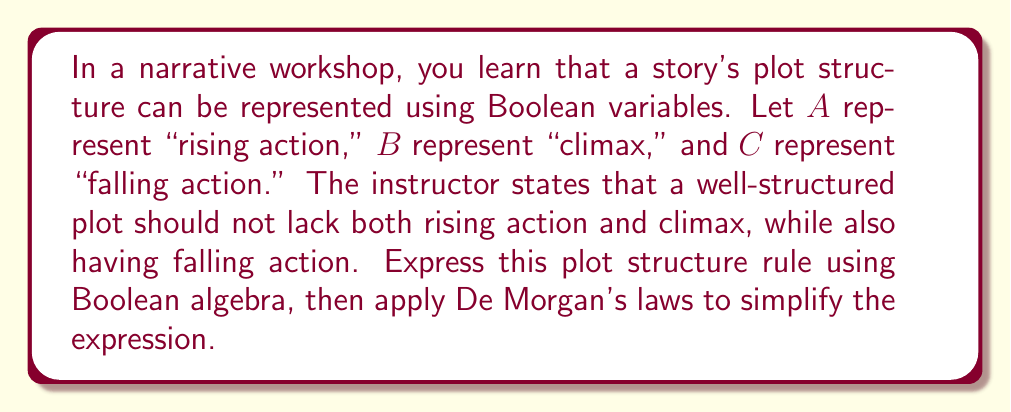Could you help me with this problem? Let's approach this step-by-step:

1. First, let's express the plot structure rule in Boolean algebra:
   $$((\overline{A} \cdot \overline{B}) + C)$$

   This reads as "not (no rising action and no climax) or falling action"

2. To apply De Morgan's laws, we need to negate this entire expression:
   $$\overline{((\overline{A} \cdot \overline{B}) + C)}$$

3. Applying the first of De Morgan's laws to the outer negation:
   $$(\overline{(\overline{A} \cdot \overline{B})} \cdot \overline{C})$$

4. Now, applying the second of De Morgan's laws to $(\overline{A} \cdot \overline{B})$:
   $$((\overline{\overline{A}} + \overline{\overline{B}}) \cdot \overline{C})$$

5. Simplify by canceling double negations:
   $$((A + B) \cdot \overline{C})$$

6. This simplified expression represents the negation of the original rule. It reads as "(rising action or climax) and not falling action", which describes a plot structure that violates the original rule.

7. To get back to the original rule, we need to negate this expression again:
   $$\overline{((A + B) \cdot \overline{C})}$$

8. Applying De Morgan's laws one last time:
   $$(\overline{(A + B)} + C)$$

9. And applying the second law to $(A + B)$:
   $$(\overline{A} \cdot \overline{B} + C)$$

This final expression is equivalent to our original rule but in a simplified form.
Answer: $(\overline{A} \cdot \overline{B} + C)$ 